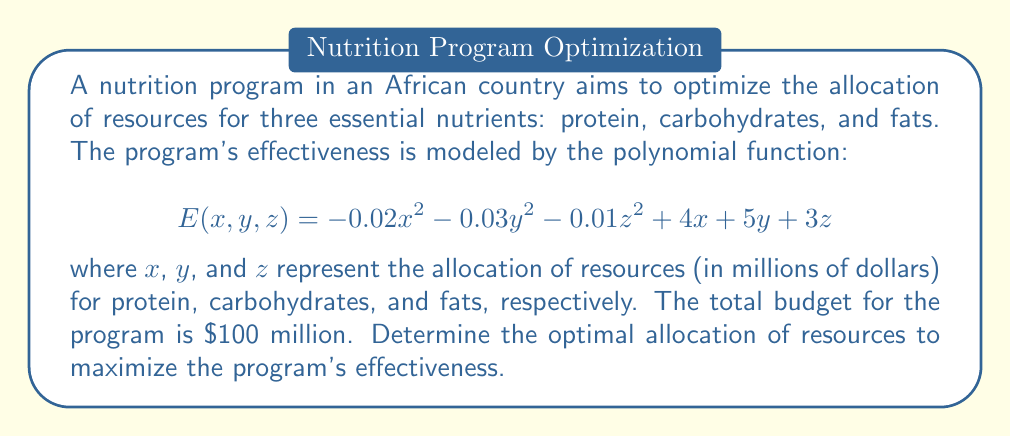Can you answer this question? To solve this optimization problem, we need to follow these steps:

1. Set up the constraint equation:
   $$x + y + z = 100$$

2. Use the method of Lagrange multipliers. Let $\lambda$ be the Lagrange multiplier. We form the Lagrangian function:
   $$L(x, y, z, \lambda) = E(x, y, z) - \lambda(x + y + z - 100)$$

3. Take partial derivatives and set them equal to zero:
   $$\frac{\partial L}{\partial x} = -0.04x + 4 - \lambda = 0$$
   $$\frac{\partial L}{\partial y} = -0.06y + 5 - \lambda = 0$$
   $$\frac{\partial L}{\partial z} = -0.02z + 3 - \lambda = 0$$
   $$\frac{\partial L}{\partial \lambda} = x + y + z - 100 = 0$$

4. Solve the system of equations:
   From the first three equations:
   $$x = \frac{4 - \lambda}{0.04} = 100 - 25\lambda$$
   $$y = \frac{5 - \lambda}{0.06} = \frac{250 - 50\lambda}{3}$$
   $$z = \frac{3 - \lambda}{0.02} = 150 - 50\lambda$$

   Substituting these into the constraint equation:
   $$(100 - 25\lambda) + (\frac{250 - 50\lambda}{3}) + (150 - 50\lambda) = 100$$

5. Solve for $\lambda$:
   $$100 - 25\lambda + \frac{250 - 50\lambda}{3} + 150 - 50\lambda = 100$$
   $$250 - 75\lambda + \frac{250 - 50\lambda}{3} = 0$$
   $$750 - 225\lambda + 250 - 50\lambda = 0$$
   $$1000 - 275\lambda = 0$$
   $$\lambda = \frac{1000}{275} = \frac{40}{11} \approx 3.64$$

6. Calculate the optimal values for $x$, $y$, and $z$:
   $$x = 100 - 25(\frac{40}{11}) = \frac{1100 - 1000}{11} = \frac{100}{11} \approx 9.09$$
   $$y = \frac{250 - 50(\frac{40}{11})}{3} = \frac{2750 - 2000}{33} = \frac{750}{33} \approx 22.73$$
   $$z = 150 - 50(\frac{40}{11}) = \frac{1650 - 2000}{11} = \frac{-350}{11} \approx 31.82$$
Answer: The optimal allocation of resources to maximize the nutrition program's effectiveness is approximately:
$9.09 million for protein,
$22.73 million for carbohydrates, and
$31.82 million for fats. 